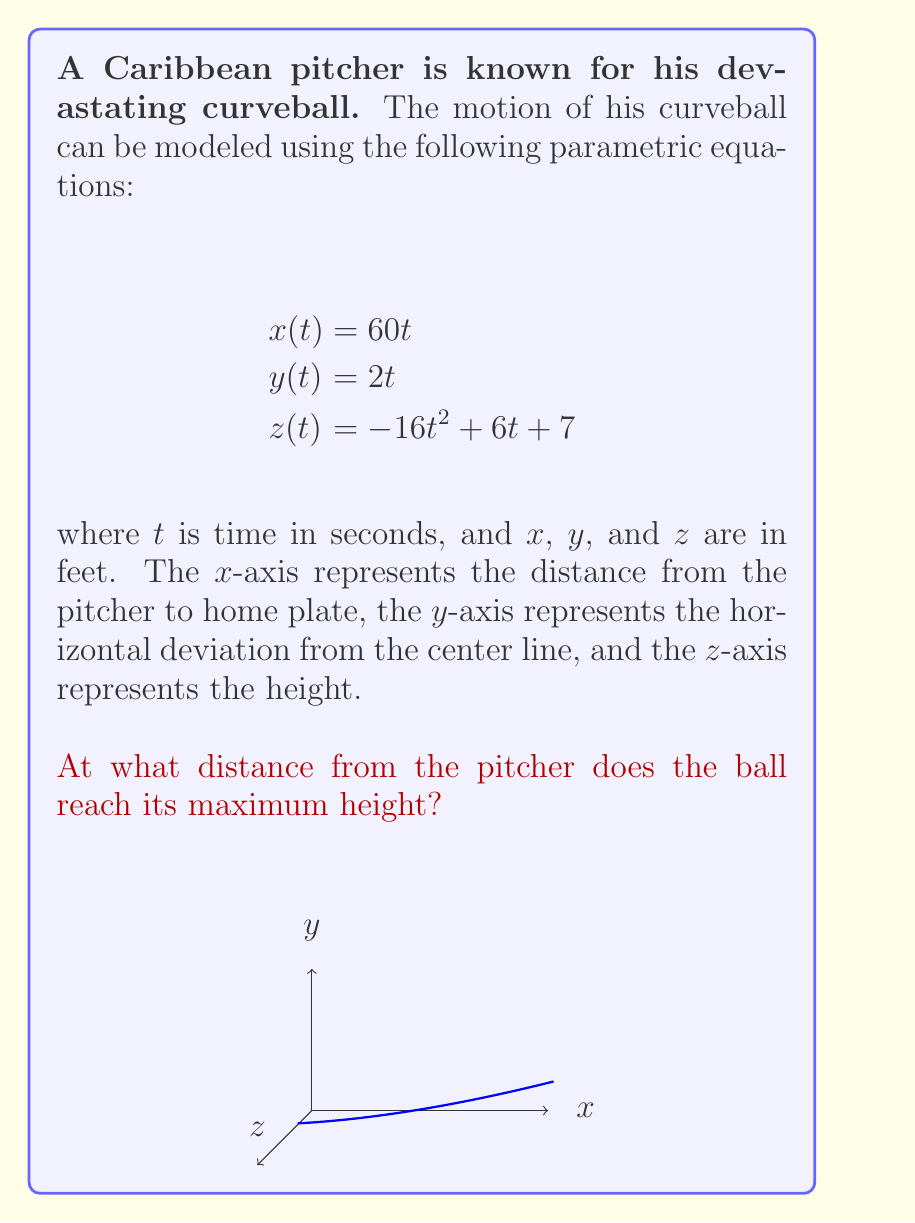Help me with this question. Let's approach this step-by-step:

1) First, we need to find when the ball reaches its maximum height. This occurs when the z-component is at its maximum.

2) The z-component is given by $z(t) = -16t^2 + 6t + 7$. To find its maximum, we need to find where its derivative equals zero.

3) The derivative of $z(t)$ is:
   $$\frac{dz}{dt} = -32t + 6$$

4) Set this equal to zero and solve for $t$:
   $$-32t + 6 = 0$$
   $$-32t = -6$$
   $$t = \frac{3}{16} = 0.1875 \text{ seconds}$$

5) This is the time at which the ball reaches its maximum height.

6) To find the distance from the pitcher at this time, we need to use the x-component equation:
   $$x(t) = 60t$$

7) Substituting our t-value:
   $$x(0.1875) = 60(0.1875) = 11.25 \text{ feet}$$

Therefore, the ball reaches its maximum height 11.25 feet from the pitcher.
Answer: 11.25 feet 